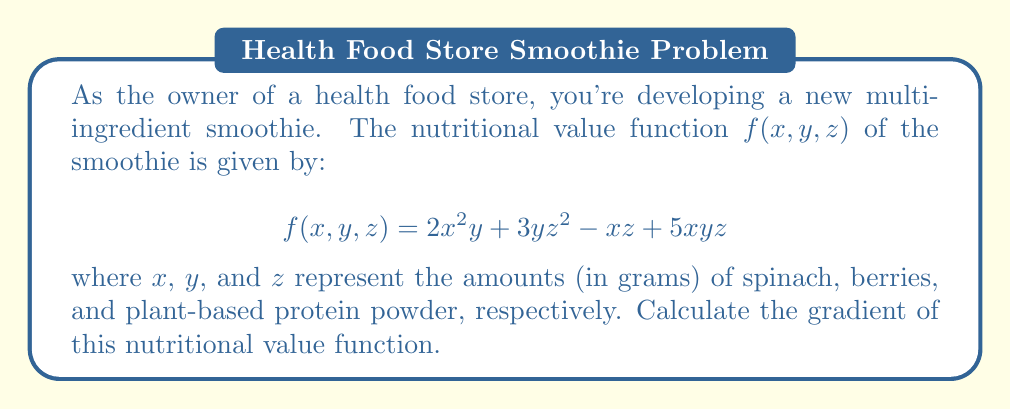Solve this math problem. To calculate the gradient of the nutritional value function, we need to find the partial derivatives with respect to each variable (x, y, and z). The gradient is a vector containing these partial derivatives.

Step 1: Calculate $\frac{\partial f}{\partial x}$
$$\frac{\partial f}{\partial x} = 4xy + 5yz - z$$

Step 2: Calculate $\frac{\partial f}{\partial y}$
$$\frac{\partial f}{\partial y} = 2x^2 + 3z^2 + 5xz$$

Step 3: Calculate $\frac{\partial f}{\partial z}$
$$\frac{\partial f}{\partial z} = 6yz - x + 5xy$$

Step 4: Form the gradient vector
The gradient is defined as:
$$\nabla f = \left(\frac{\partial f}{\partial x}, \frac{\partial f}{\partial y}, \frac{\partial f}{\partial z}\right)$$

Substituting our calculated partial derivatives:
$$\nabla f = (4xy + 5yz - z, 2x^2 + 3z^2 + 5xz, 6yz - x + 5xy)$$
Answer: $\nabla f = (4xy + 5yz - z, 2x^2 + 3z^2 + 5xz, 6yz - x + 5xy)$ 